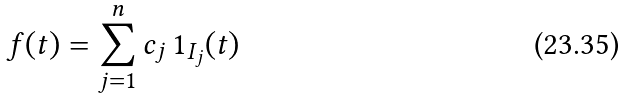Convert formula to latex. <formula><loc_0><loc_0><loc_500><loc_500>f ( t ) = \sum _ { j = 1 } ^ { n } c _ { j } \, { 1 } _ { I _ { j } } ( t )</formula> 